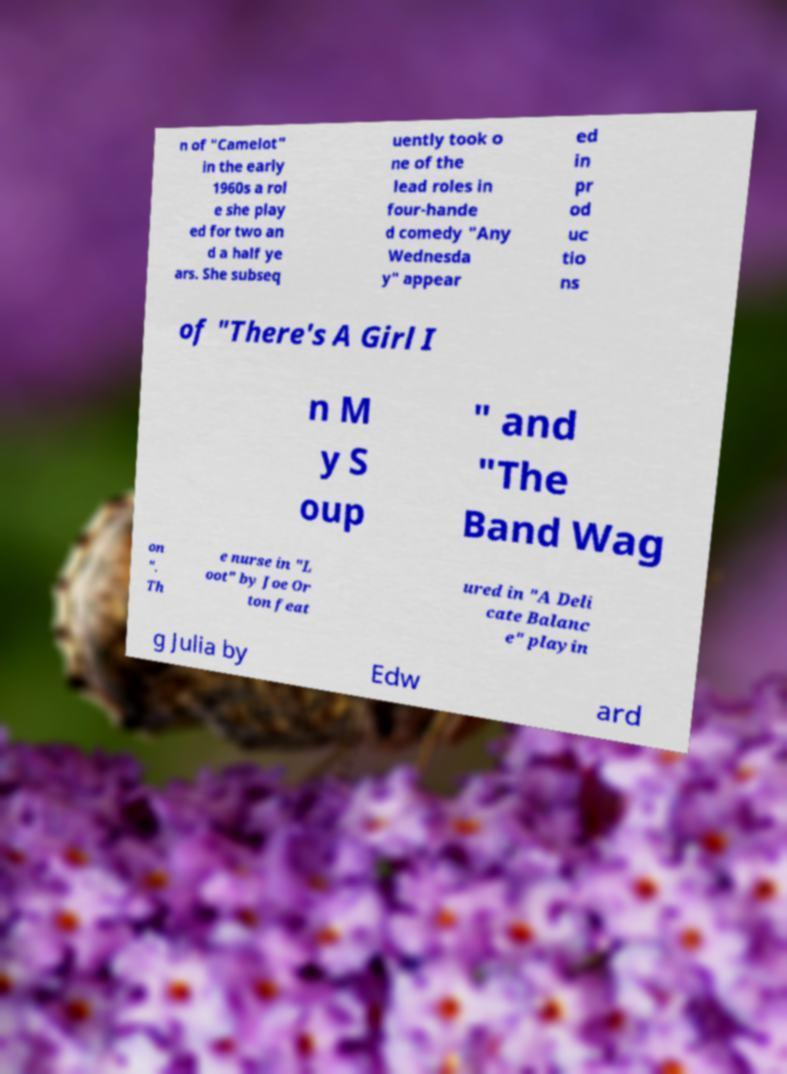There's text embedded in this image that I need extracted. Can you transcribe it verbatim? n of "Camelot" in the early 1960s a rol e she play ed for two an d a half ye ars. She subseq uently took o ne of the lead roles in four-hande d comedy "Any Wednesda y" appear ed in pr od uc tio ns of "There's A Girl I n M y S oup " and "The Band Wag on ". Th e nurse in "L oot" by Joe Or ton feat ured in "A Deli cate Balanc e" playin g Julia by Edw ard 